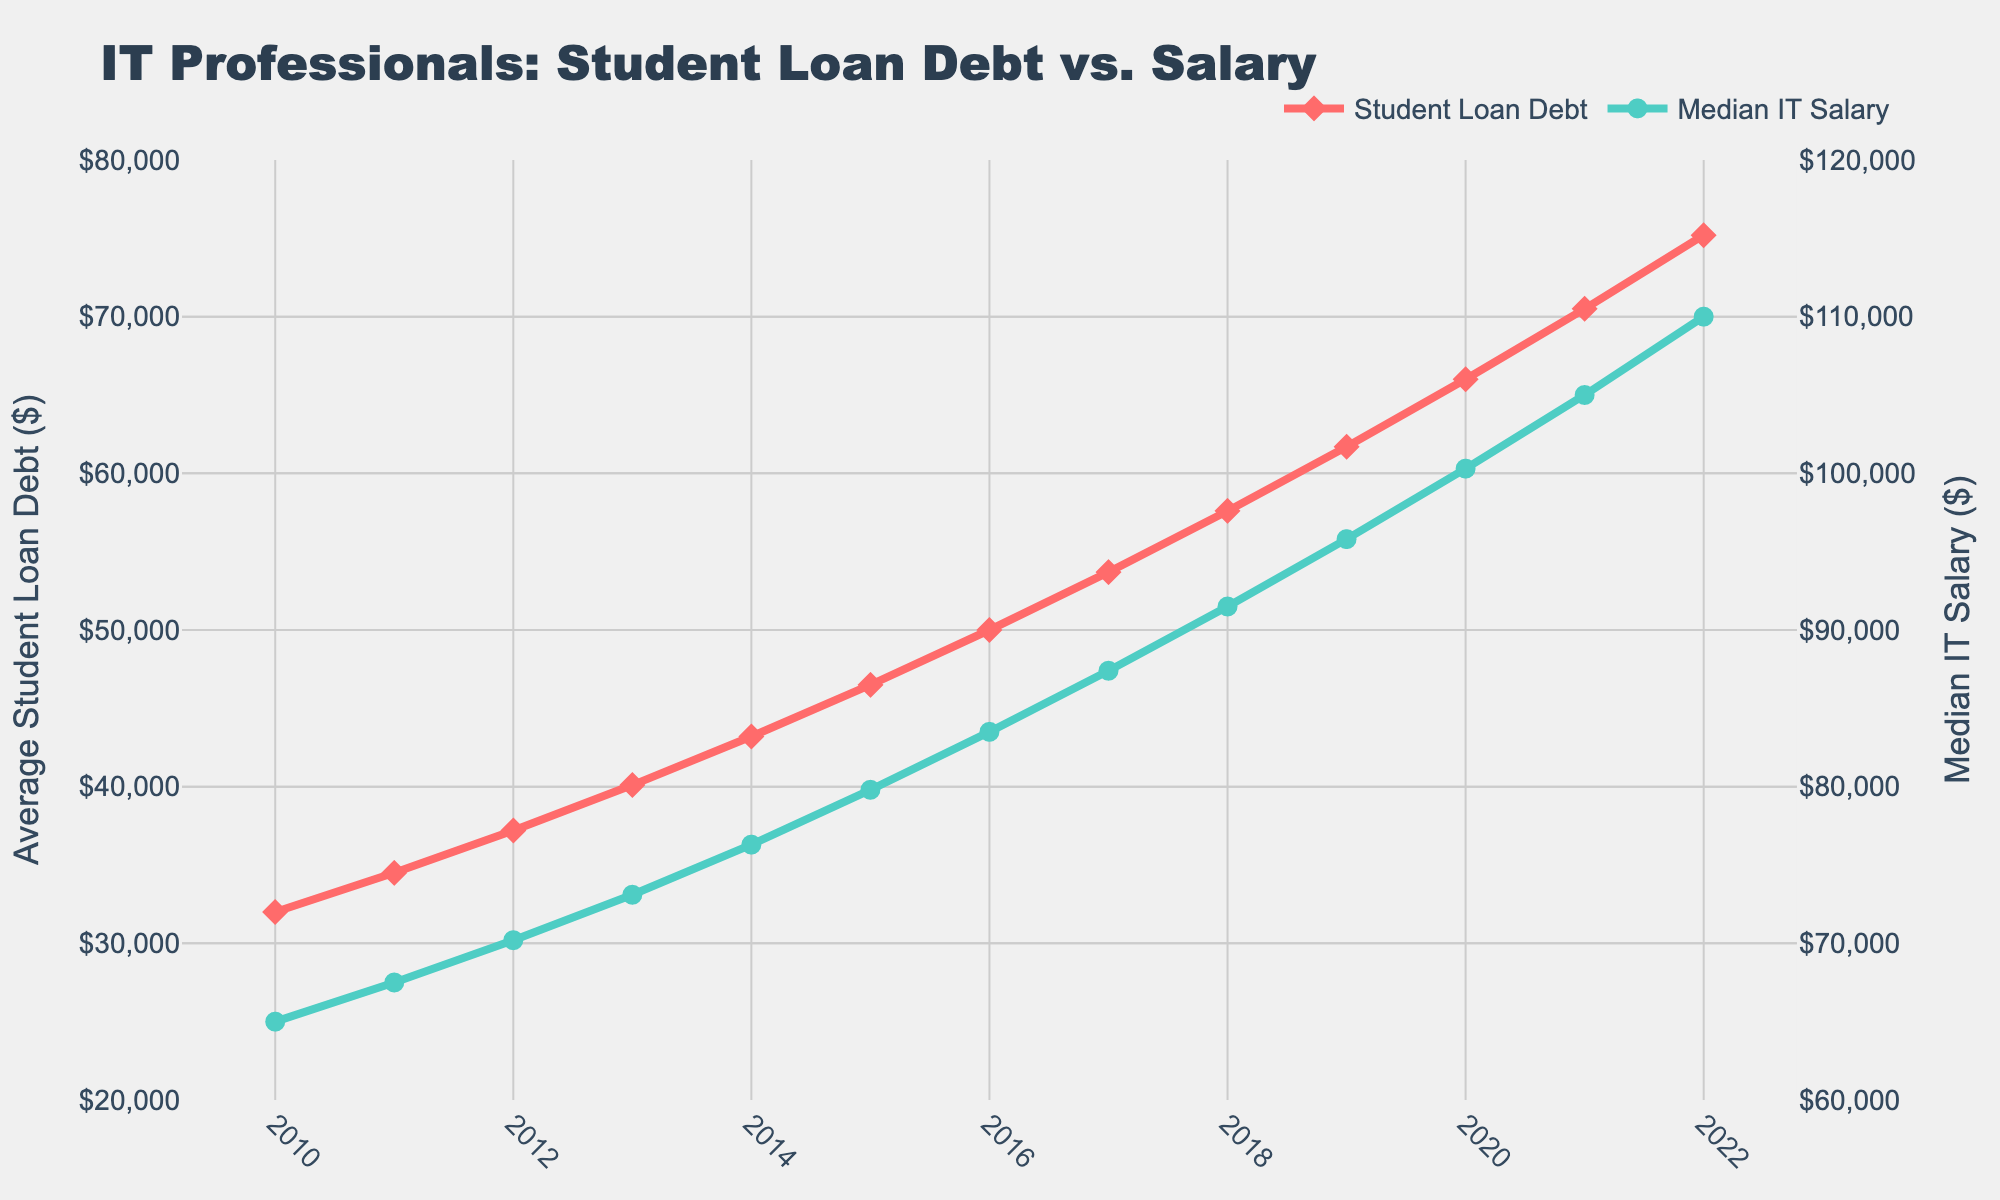What is the difference between the Average Student Loan Debt in 2012 and 2022? First, find the loan debt values for 2012 and 2022, which are $37,200 and $75,200 respectively. Subtract the former from the latter: $75,200 - $37,200 = $38,000.
Answer: $38,000 In what year did the Median IT Salary surpass $80,000? Identify the year where the Median IT Salary first exceeds $80,000. Checking the provided data, this happens in 2015 where the salary is $79,800 and then exceeds $80,000 in 2016 at $83,500.
Answer: 2016 By how much did the Average Student Loan Debt increase between 2015 and 2018? Calculate the loan debt in 2015 ($46,500) and in 2018 ($57,600), then subtract the former from the latter: $57,600 - $46,500 = $11,100.
Answer: $11,100 Which had a higher growth rate between 2011 and 2021, Average Student Loan Debt or Median IT Salary? Calculate the percentage growth for each over the stated period. 
For Average Student Loan Debt: (($70,500 - $34,500) / $34,500) * 100 = 104.35%
For Median IT Salary: (($105,000 - $67,500) / $67,500) * 100 = 55.56%
Compare the two growth rates: 104.35% > 55.56%.
Answer: Average Student Loan Debt In which year did the Average Student Loan Debt reach $50,000? Scan the data to find the year when the loan debt value reaches or surpasses $50,000. It is $50,000 in 2016.
Answer: 2016 How much more was the Median IT Salary than the Average Student Loan Debt in 2020? Find the values for both metrics in 2020. The Median IT Salary is $100,300 and the Average Student Loan Debt is $66,000. Subtract the loan debt from the salary: $100,300 - $66,000 = $34,300.
Answer: $34,300 What is the trend of the Average Student Loan Debt over the given years? Observe the line representing the Average Student Loan Debt. It consistently increases every year from 2010 ($32,000) to 2022 ($75,200).
Answer: Consistent increase How does the Median IT Salary in 2010 compare with the Average Student Loan Debt in 2022? Find both numbers: the Median IT Salary in 2010 is $65,000, and the Average Student Loan Debt in 2022 is $75,200. Compare them directly: $65,000 (salary) < $75,200 (debt).
Answer: Median IT Salary in 2010 was less than Average Student Loan Debt in 2022 